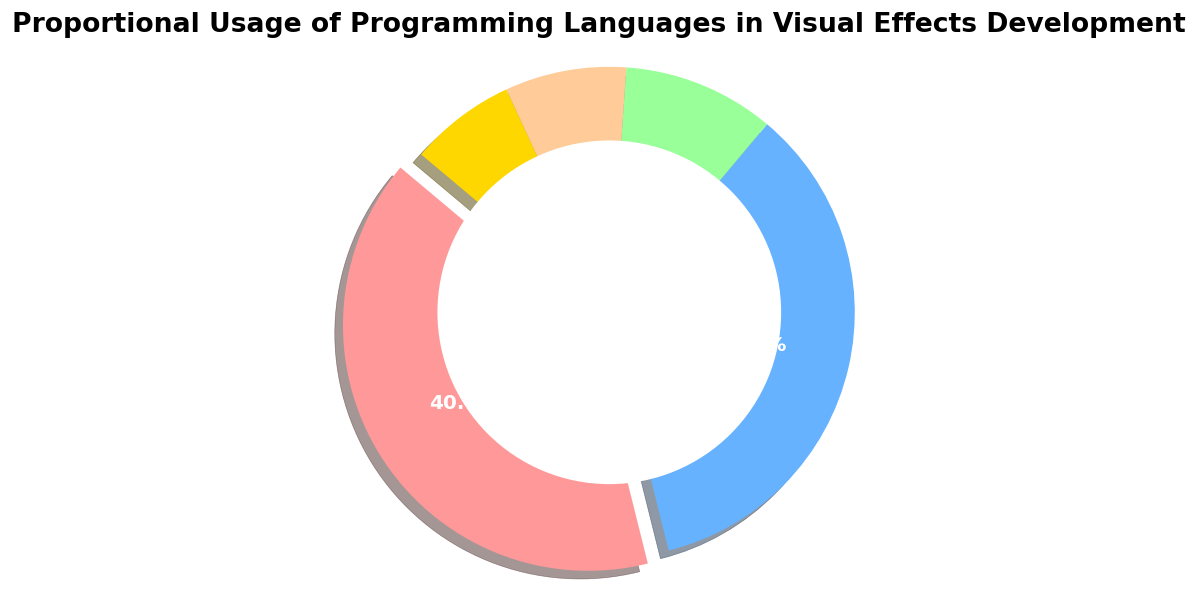What is the most used programming language in visual effects development? The pie chart shows the proportional usage of different programming languages. The segment representing C++ is the largest.
Answer: C++ What is the percentage difference between the usage of C++ and Python? The pie chart indicates C++ usage at 40% and Python usage at 35%. Subtracting the smaller percentage from the larger one, 40% - 35% = 5%.
Answer: 5% Which language has the smallest proportional usage and what is its percentage? The pie chart includes segments for each programming language, with the smallest segment representing "Other" at 7%.
Answer: Other, 7% By how much does the usage of GLSL exceed the usage of HLSL? The proportional usage for GLSL is 10%, and for HLSL, it is 8%. Subtracting the smaller number from the larger one, 10% - 8% = 2%.
Answer: 2% What portion of the total usage is shared by HLSL and Other combined? The pie chart shows that HLSL has 8% and Other has 7%. Adding these two values together, we get 8% + 7% = 15%.
Answer: 15% How is the C++ segment visually distinct in the pie chart? The pie chart uses different visual styles for each segment, and C++ is visually distinct because it is slightly pulled out from the rest of the pie (exploded).
Answer: It is exploded What percentage do non-Python languages collectively represent? The pie chart shows Python at 35%. Subtracting Python's percentage from 100%, we get 100% - 35% = 65%.
Answer: 65% Which languages together constitute less than 20% of usage? The pie chart shows the following usage proportions: GLSL (10%), HLSL (8%), and Other (7%). Adding GLSL and HLSL gives 10% + 8% = 18%, which is less than 20%.
Answer: GLSL and HLSL What portion of all usage do C++ and Python together account for? The pie chart shows C++ usage at 40% and Python usage at 35%. Adding these together, 40% + 35% = 75%.
Answer: 75% Which segment is represented by the green color? The pie chart uses specific colors for each segment. The green segment corresponds to GLSL.
Answer: GLSL 